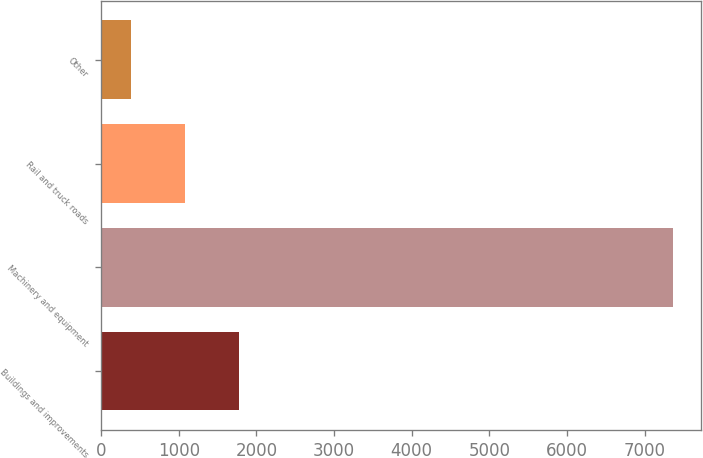<chart> <loc_0><loc_0><loc_500><loc_500><bar_chart><fcel>Buildings and improvements<fcel>Machinery and equipment<fcel>Rail and truck roads<fcel>Other<nl><fcel>1776.4<fcel>7358<fcel>1078.7<fcel>381<nl></chart> 